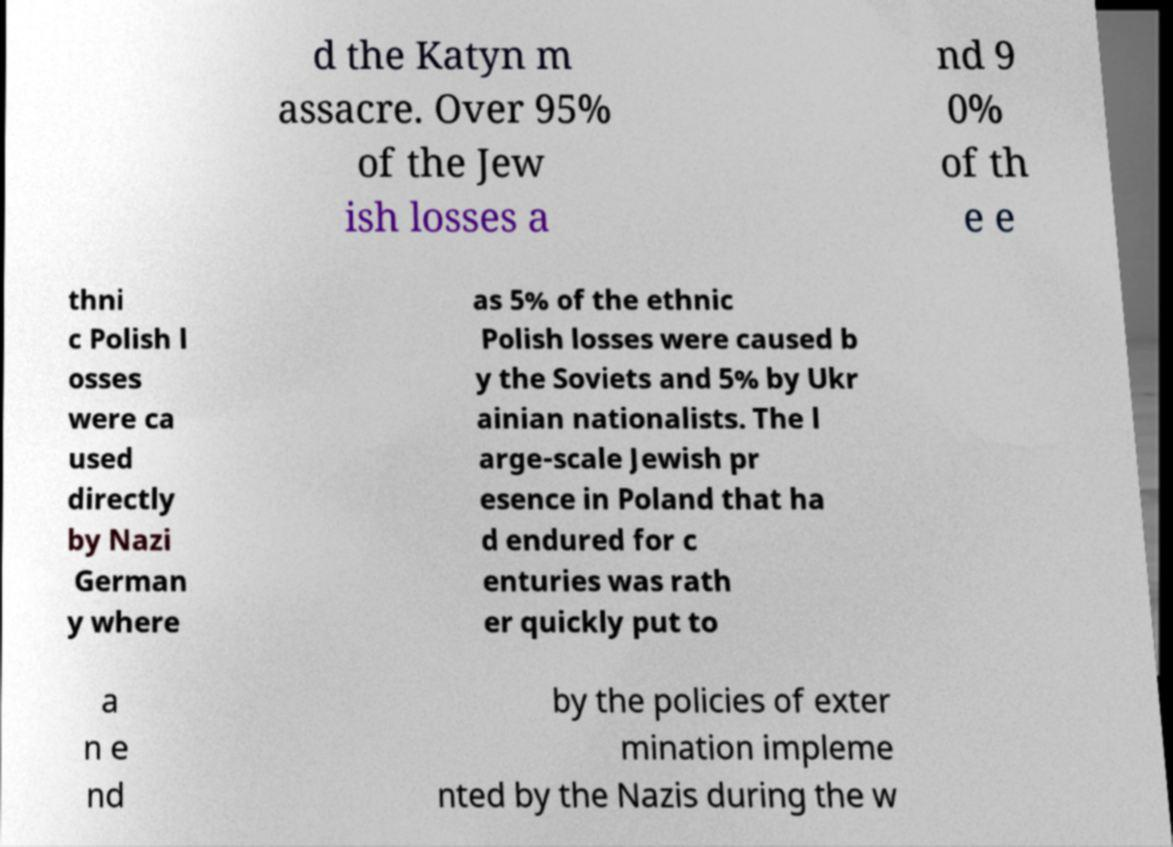Please identify and transcribe the text found in this image. d the Katyn m assacre. Over 95% of the Jew ish losses a nd 9 0% of th e e thni c Polish l osses were ca used directly by Nazi German y where as 5% of the ethnic Polish losses were caused b y the Soviets and 5% by Ukr ainian nationalists. The l arge-scale Jewish pr esence in Poland that ha d endured for c enturies was rath er quickly put to a n e nd by the policies of exter mination impleme nted by the Nazis during the w 